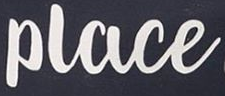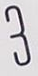What words can you see in these images in sequence, separated by a semicolon? Place; 3 